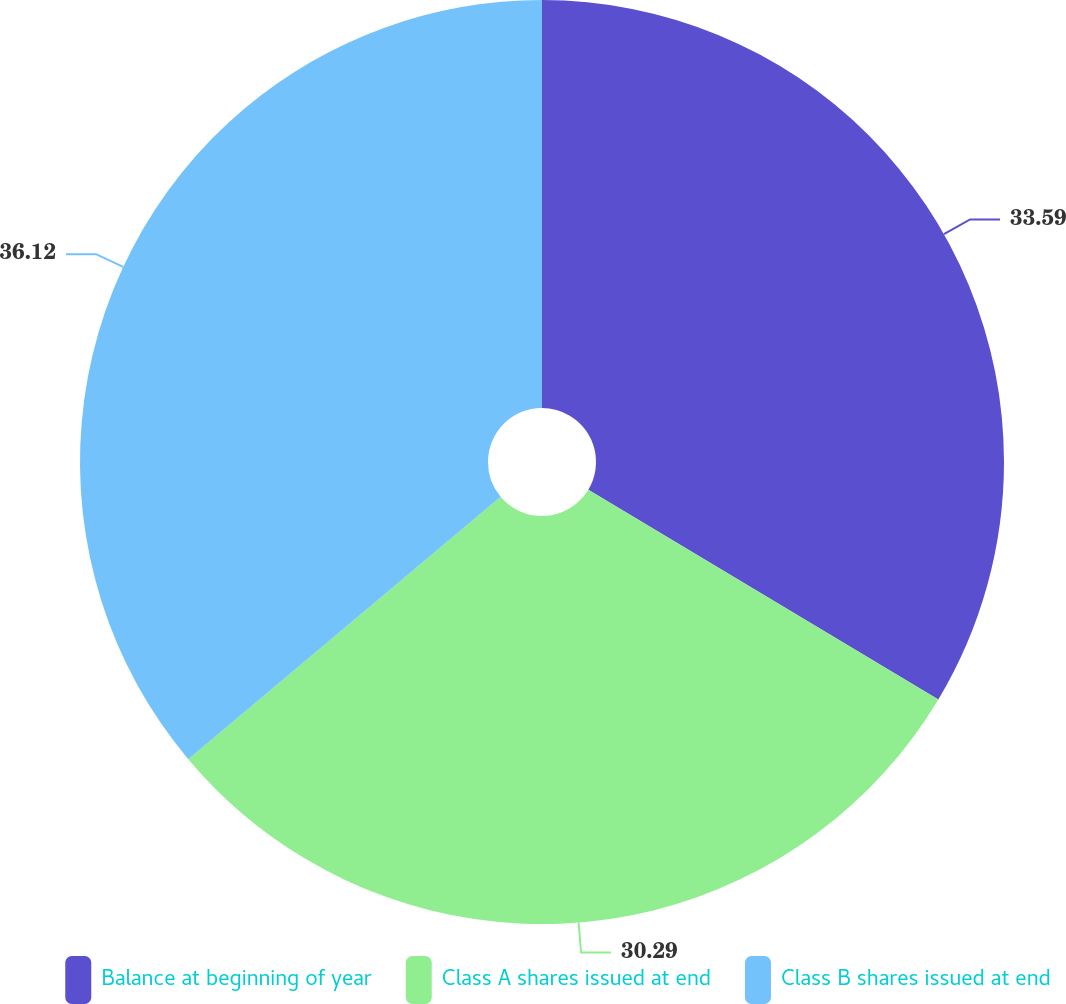<chart> <loc_0><loc_0><loc_500><loc_500><pie_chart><fcel>Balance at beginning of year<fcel>Class A shares issued at end<fcel>Class B shares issued at end<nl><fcel>33.59%<fcel>30.29%<fcel>36.12%<nl></chart> 